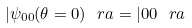Convert formula to latex. <formula><loc_0><loc_0><loc_500><loc_500>| \psi _ { 0 0 } ( \theta = 0 ) \ r a = | 0 0 \ r a</formula> 